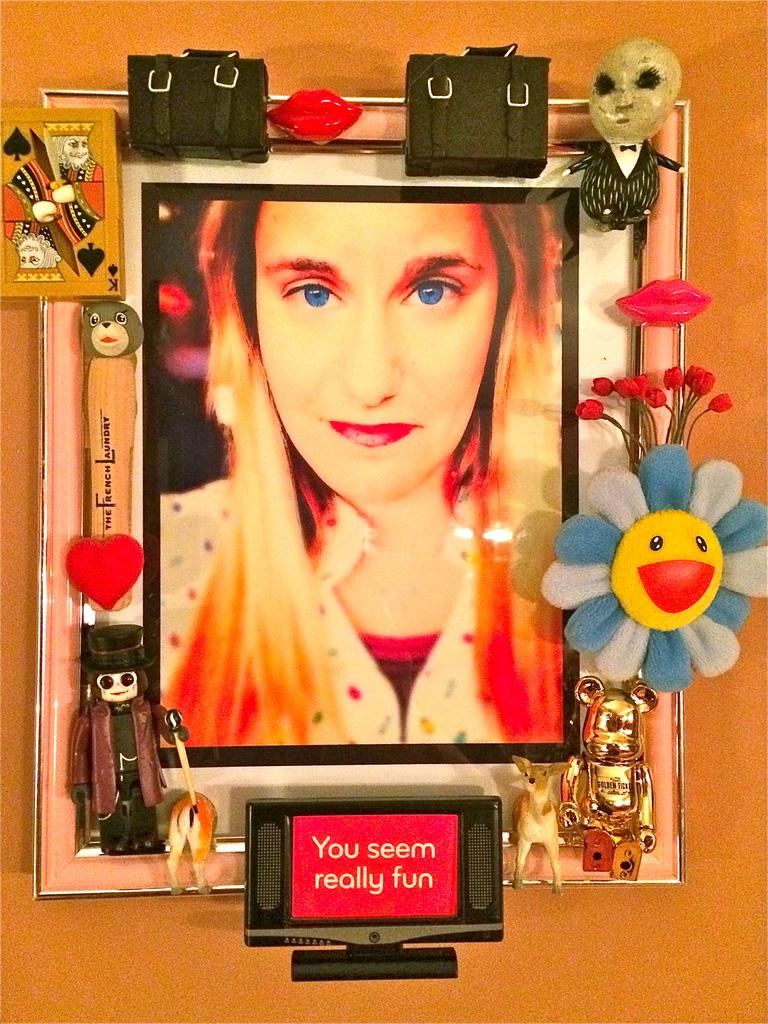What is the main subject of the image? The main subject of the image is a woman's photograph. How is the photograph displayed in the image? The photograph is inserted in a photo frame. How many waves can be seen in the image? There are no waves present in the image; it features a woman's photograph in a photo frame. What is the amount of kittens visible in the image? There are no kittens present in the image. 